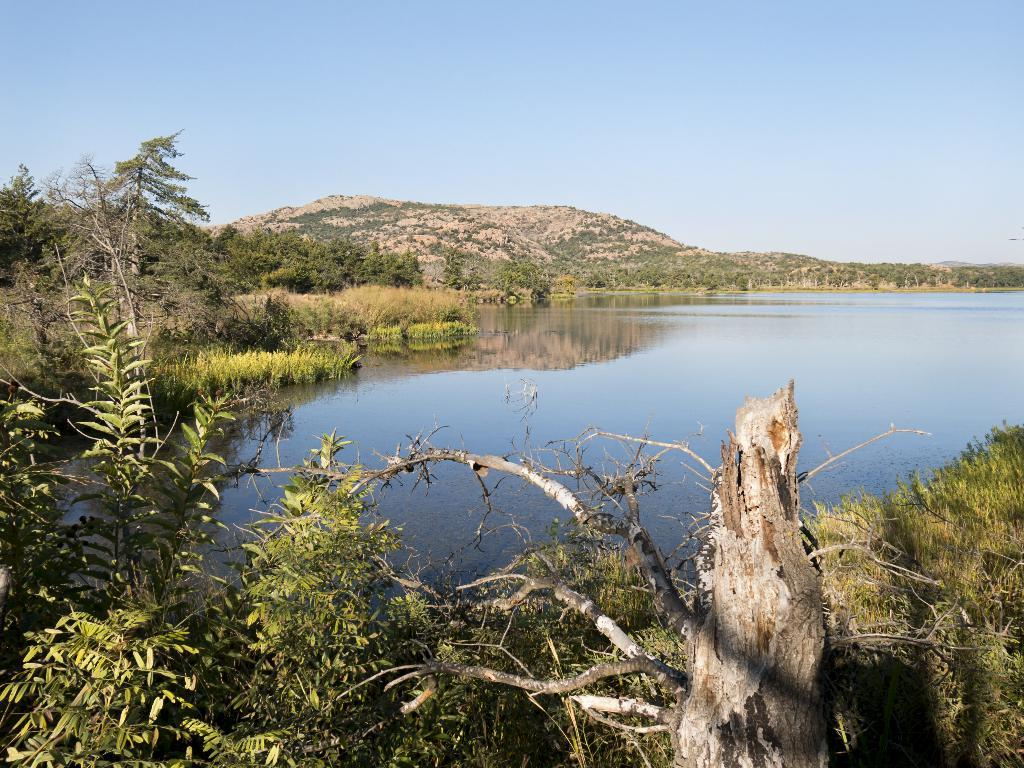What is one of the natural elements present in the image? There is water in the image. What type of vegetation can be seen in the image? There is grass, plants, and trees in the image. What part of the sky is visible in the image? The sky is visible in the image. What geographical feature is present in the background of the image? There is a hill in the background of the image. What type of lock is securing the border in the image? There is no lock or border present in the image. What is the sun doing in the image? The sun is not depicted in the image; only the sky is visible. 